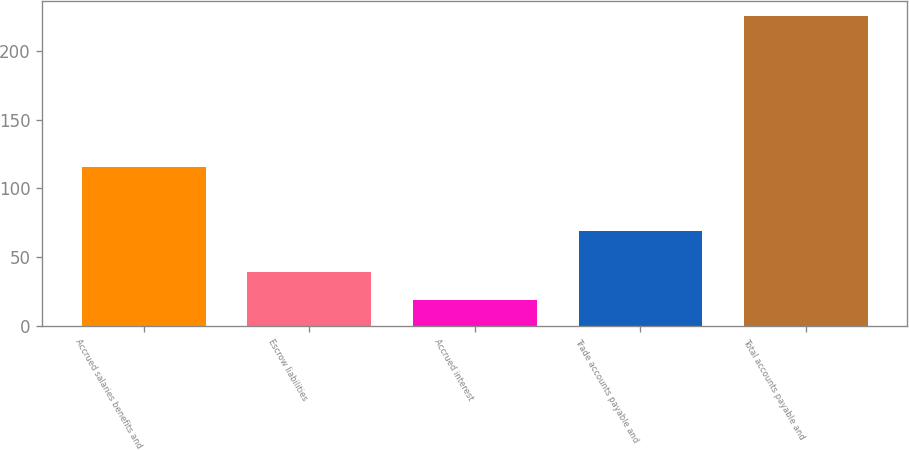Convert chart. <chart><loc_0><loc_0><loc_500><loc_500><bar_chart><fcel>Accrued salaries benefits and<fcel>Escrow liabilities<fcel>Accrued interest<fcel>Trade accounts payable and<fcel>Total accounts payable and<nl><fcel>115.3<fcel>39.01<fcel>18.3<fcel>68.9<fcel>225.4<nl></chart> 